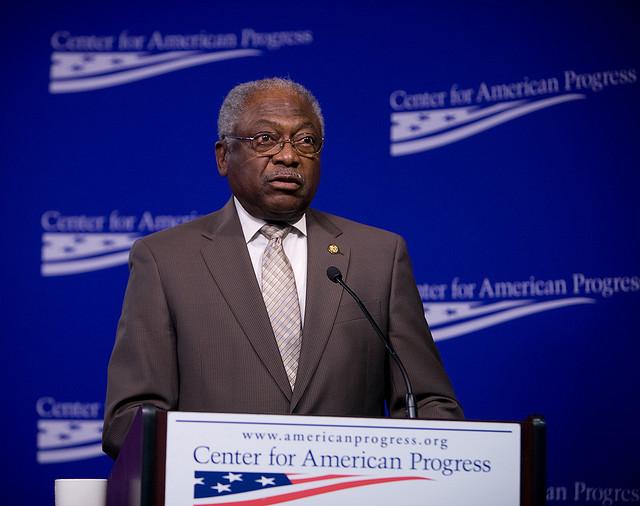What country is this man likely in?
Answer briefly. Usa. What is the person doing there?
Write a very short answer. Speaking. Is the man wearing glasses?
Write a very short answer. Yes. 